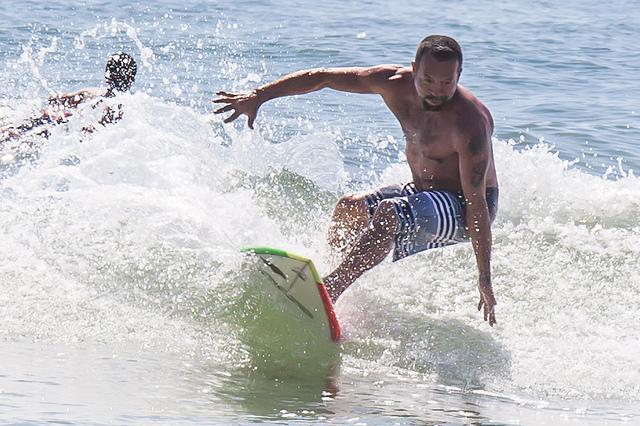Is there stripes on the surfer's shorts?
Be succinct. Yes. Is the surfer on a tall wave?
Give a very brief answer. No. What is the meaning of the facial expression on the individual on the surfboard?
Give a very brief answer. Concentration. 